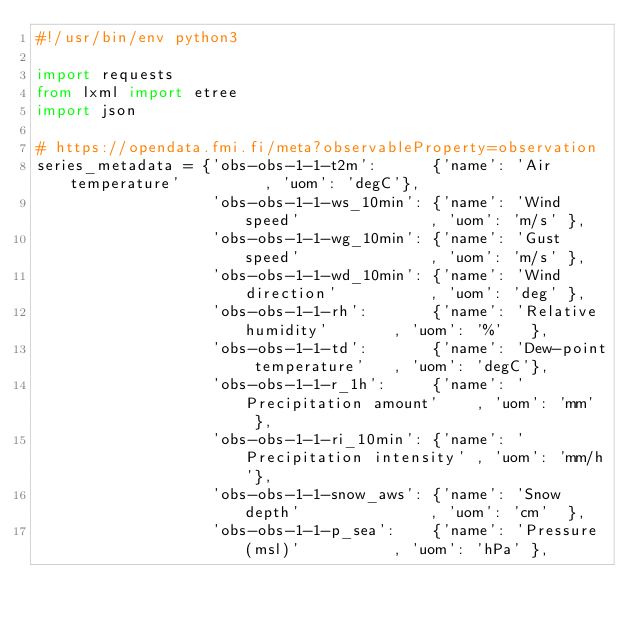Convert code to text. <code><loc_0><loc_0><loc_500><loc_500><_Python_>#!/usr/bin/env python3

import requests
from lxml import etree
import json

# https://opendata.fmi.fi/meta?observableProperty=observation
series_metadata = {'obs-obs-1-1-t2m':      {'name': 'Air temperature'         , 'uom': 'degC'},
                   'obs-obs-1-1-ws_10min': {'name': 'Wind speed'              , 'uom': 'm/s' },
                   'obs-obs-1-1-wg_10min': {'name': 'Gust speed'              , 'uom': 'm/s' },
                   'obs-obs-1-1-wd_10min': {'name': 'Wind direction'          , 'uom': 'deg' },
                   'obs-obs-1-1-rh':       {'name': 'Relative humidity'       , 'uom': '%'   },
                   'obs-obs-1-1-td':       {'name': 'Dew-point temperature'   , 'uom': 'degC'},
                   'obs-obs-1-1-r_1h':     {'name': 'Precipitation amount'    , 'uom': 'mm'  },
                   'obs-obs-1-1-ri_10min': {'name': 'Precipitation intensity' , 'uom': 'mm/h'},
                   'obs-obs-1-1-snow_aws': {'name': 'Snow depth'              , 'uom': 'cm'  },
                   'obs-obs-1-1-p_sea':    {'name': 'Pressure (msl)'          , 'uom': 'hPa' },</code> 